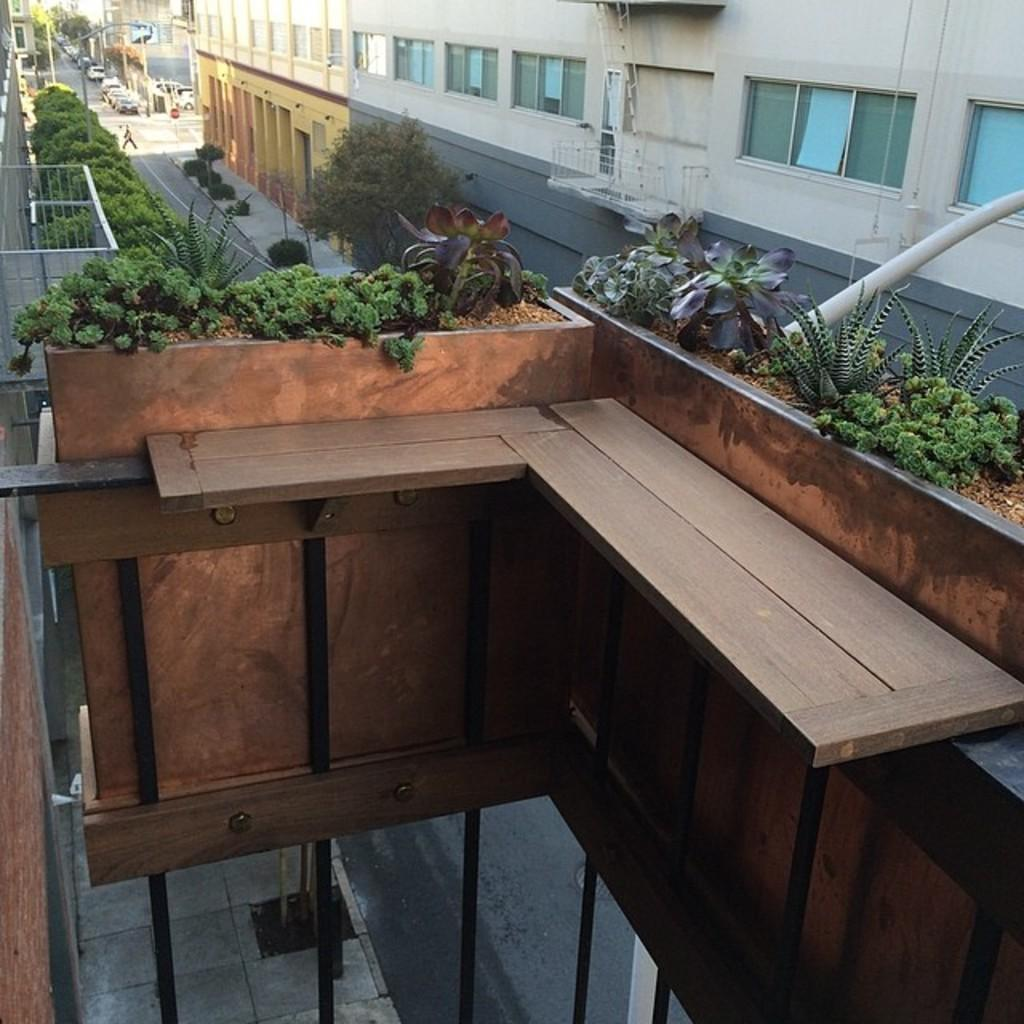What type of living organisms can be seen in the image? Plants are visible in the image. What objects are used for cooking in the image? Grills are present in the image. What type of transportation is visible in the image? Motor vehicles are present in the image. What type of structures can be seen in the image? Buildings are visible in the image. Can you describe the person's location in the image? A person is visible on the road in the image. Is there a ghost holding an umbrella in the image? No, there is no ghost or umbrella present in the image. Can you describe the eye color of the person visible on the road in the image? There is no information about the person's eye color in the image. 